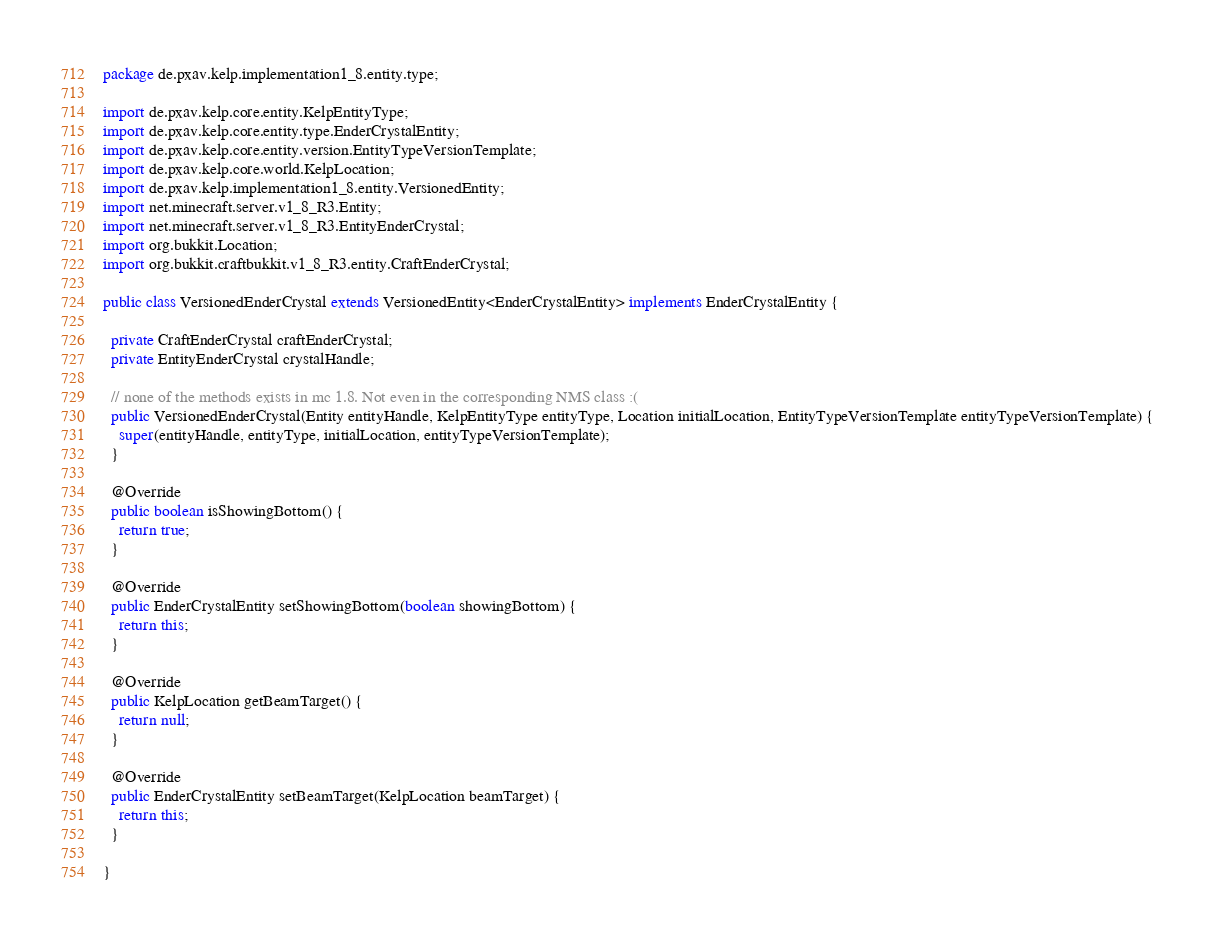Convert code to text. <code><loc_0><loc_0><loc_500><loc_500><_Java_>package de.pxav.kelp.implementation1_8.entity.type;

import de.pxav.kelp.core.entity.KelpEntityType;
import de.pxav.kelp.core.entity.type.EnderCrystalEntity;
import de.pxav.kelp.core.entity.version.EntityTypeVersionTemplate;
import de.pxav.kelp.core.world.KelpLocation;
import de.pxav.kelp.implementation1_8.entity.VersionedEntity;
import net.minecraft.server.v1_8_R3.Entity;
import net.minecraft.server.v1_8_R3.EntityEnderCrystal;
import org.bukkit.Location;
import org.bukkit.craftbukkit.v1_8_R3.entity.CraftEnderCrystal;

public class VersionedEnderCrystal extends VersionedEntity<EnderCrystalEntity> implements EnderCrystalEntity {

  private CraftEnderCrystal craftEnderCrystal;
  private EntityEnderCrystal crystalHandle;

  // none of the methods exists in mc 1.8. Not even in the corresponding NMS class :(
  public VersionedEnderCrystal(Entity entityHandle, KelpEntityType entityType, Location initialLocation, EntityTypeVersionTemplate entityTypeVersionTemplate) {
    super(entityHandle, entityType, initialLocation, entityTypeVersionTemplate);
  }

  @Override
  public boolean isShowingBottom() {
    return true;
  }

  @Override
  public EnderCrystalEntity setShowingBottom(boolean showingBottom) {
    return this;
  }

  @Override
  public KelpLocation getBeamTarget() {
    return null;
  }

  @Override
  public EnderCrystalEntity setBeamTarget(KelpLocation beamTarget) {
    return this;
  }

}
</code> 